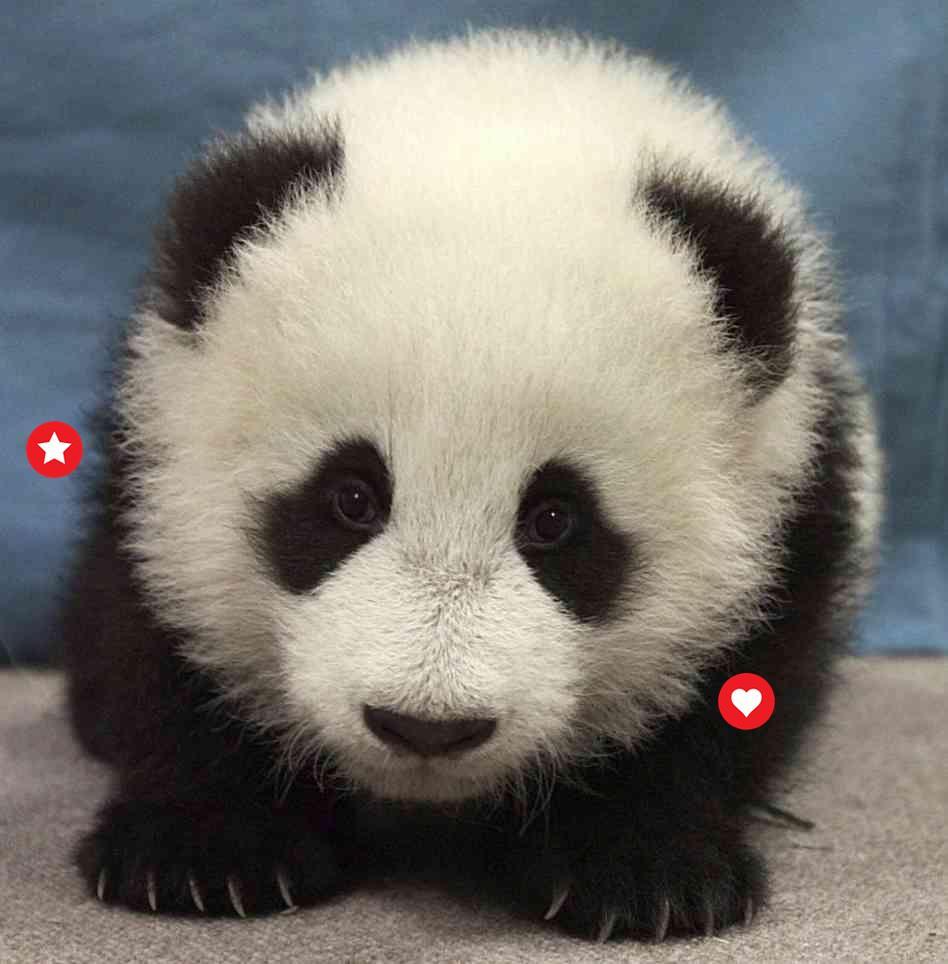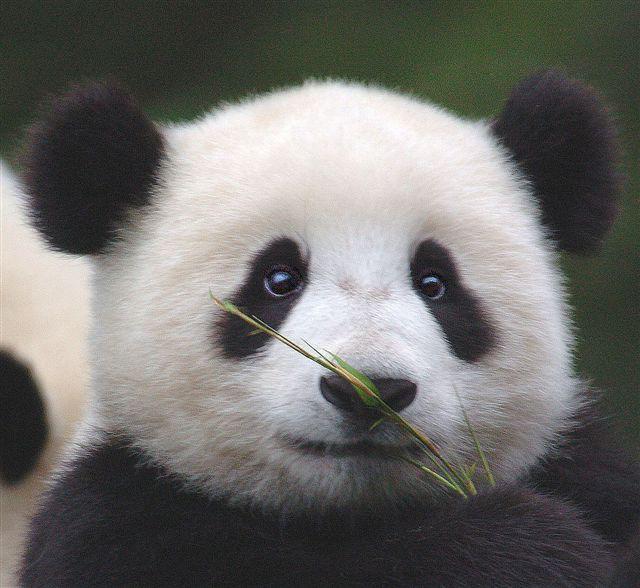The first image is the image on the left, the second image is the image on the right. Considering the images on both sides, is "A panda is hanging on a branch" valid? Answer yes or no. No. 